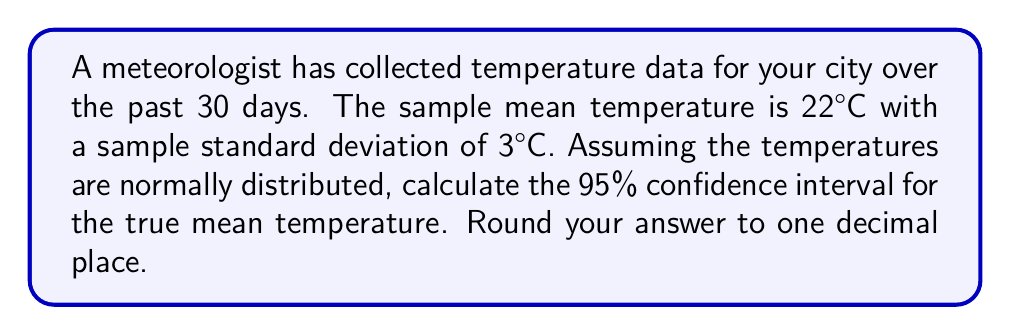Give your solution to this math problem. To calculate the confidence interval, we'll follow these steps:

1) The formula for the confidence interval is:

   $$\bar{x} \pm t_{\alpha/2, n-1} \cdot \frac{s}{\sqrt{n}}$$

   Where:
   $\bar{x}$ is the sample mean
   $t_{\alpha/2, n-1}$ is the t-value for a 95% confidence level with n-1 degrees of freedom
   $s$ is the sample standard deviation
   $n$ is the sample size

2) We know:
   $\bar{x} = 22°C$
   $s = 3°C$
   $n = 30$
   Confidence level = 95%, so $\alpha = 0.05$

3) For a 95% confidence interval with 29 degrees of freedom (n-1 = 30-1 = 29), the t-value is approximately 2.045.

4) Plugging into the formula:

   $$22 \pm 2.045 \cdot \frac{3}{\sqrt{30}}$$

5) Simplify:
   $$22 \pm 2.045 \cdot \frac{3}{5.477}$$
   $$22 \pm 2.045 \cdot 0.548$$
   $$22 \pm 1.121$$

6) Therefore, the confidence interval is:
   $$(22 - 1.121, 22 + 1.121)$$
   $$(20.879, 23.121)$$

7) Rounding to one decimal place:
   $$(20.9°C, 23.1°C)$$
Answer: (20.9°C, 23.1°C) 